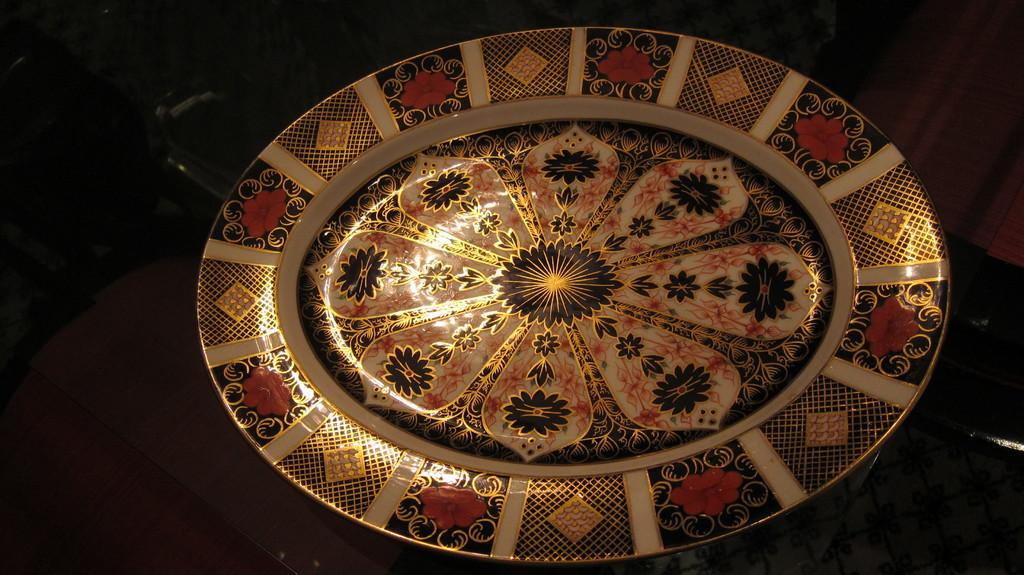What can be seen on the platform in the image? There are designs on the platform in the image. How would you describe the overall lighting in the image? The background of the image is dark. Despite the dark background, are there any objects visible? Yes, objects are visible in the dark background. What type of argument is taking place between the parcel and the army in the image? There is no parcel or army present in the image, so no such argument can be observed. 